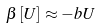<formula> <loc_0><loc_0><loc_500><loc_500>\beta \left [ U \right ] \approx - b U</formula> 